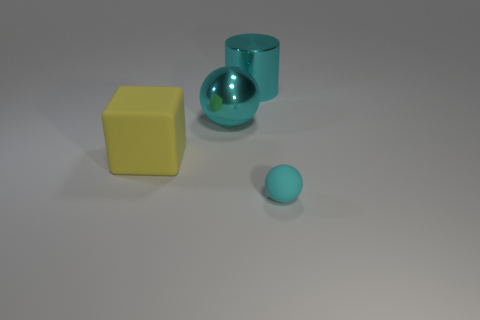Are there the same number of matte balls left of the big yellow cube and gray rubber cubes?
Your answer should be very brief. Yes. There is a matte block; are there any big yellow rubber blocks behind it?
Give a very brief answer. No. What size is the sphere that is behind the matte object that is behind the rubber thing that is in front of the yellow rubber cube?
Keep it short and to the point. Large. There is a big thing that is on the left side of the big cyan shiny ball; does it have the same shape as the thing that is on the right side of the cyan cylinder?
Your response must be concise. No. The metallic object that is the same shape as the tiny cyan matte thing is what size?
Your response must be concise. Large. How many tiny cyan balls are made of the same material as the cyan cylinder?
Keep it short and to the point. 0. What material is the big cyan cylinder?
Your answer should be very brief. Metal. There is a big thing behind the cyan sphere behind the cyan rubber thing; what is its shape?
Offer a very short reply. Cylinder. The matte object right of the big yellow object has what shape?
Give a very brief answer. Sphere. What number of other big metallic balls are the same color as the metallic ball?
Give a very brief answer. 0. 